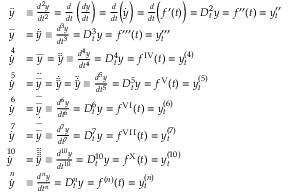Convert formula to latex. <formula><loc_0><loc_0><loc_500><loc_500>{ \begin{array} { r l } { { \ddot { y } } } & { \equiv \frac { d ^ { 2 } y } { d t ^ { 2 } } = { \frac { d } { d t } } \left ( { \frac { d y } { d t } } \right ) = { \frac { d } { d t } } { \left ( } { \dot { y } } { \right ) } = { \frac { d } { d t } } { \left ( } f ^ { \prime } ( t ) { \right ) } = D _ { t } ^ { 2 } y = f ^ { \prime \prime } ( t ) = y _ { t } ^ { \prime \prime } } \\ { { \overset { \dots } { y } } } & { = { \dot { \ddot { y } } } \equiv \frac { d ^ { 3 } y } { d t ^ { 3 } } = D _ { t } ^ { 3 } y = f ^ { \prime \prime \prime } ( t ) = y _ { t } ^ { \prime \prime \prime } } \\ { { \overset { \, 4 } { \dot { y } } } } & { = { \overset { \cdots } { y } } = { \ddot { \ddot { y } } } \equiv \frac { d ^ { 4 } y } { d t ^ { 4 } } = D _ { t } ^ { 4 } y = f ^ { I V } ( t ) = y _ { t } ^ { ( 4 ) } } \\ { { \overset { \, 5 } { \dot { y } } } } & { = { \ddot { \overset { \dots } { y } } } = { \dot { \ddot { \ddot { y } } } } = { \ddot { \dot { \ddot { y } } } } \equiv \frac { d ^ { 5 } y } { d t ^ { 5 } } = D _ { t } ^ { 5 } y = f ^ { V } ( t ) = y _ { t } ^ { ( 5 ) } } \\ { { \overset { \, 6 } { \dot { y } } } } & { = { \overset { \dots } { \overset { \dots } { y } } } \equiv \frac { d ^ { 6 } y } { d t ^ { 6 } } = D _ { t } ^ { 6 } y = f ^ { V I } ( t ) = y _ { t } ^ { ( 6 ) } } \\ { { \overset { \, 7 } { \dot { y } } } } & { = { \dot { \overset { \dots } { \overset { \dots } { y } } } } \equiv \frac { d ^ { 7 } y } { d t ^ { 7 } } = D _ { t } ^ { 7 } y = f ^ { V I I } ( t ) = y _ { t } ^ { ( 7 ) } } \\ { { \overset { \, 1 0 } { \dot { y } } } } & { = { \ddot { \ddot { \ddot { \ddot { \ddot { y } } } } } } \equiv \frac { d ^ { 1 0 } y } { d t ^ { 1 0 } } = D _ { t } ^ { 1 0 } y = f ^ { X } ( t ) = y _ { t } ^ { ( 1 0 ) } } \\ { { \overset { \, n } { \dot { y } } } } & { \equiv \frac { d ^ { n } y } { d t ^ { n } } = D _ { t } ^ { n } y = f ^ { ( n ) } ( t ) = y _ { t } ^ { ( n ) } } \end{array} }</formula> 